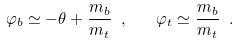Convert formula to latex. <formula><loc_0><loc_0><loc_500><loc_500>\varphi _ { b } \simeq - \theta + \frac { m _ { b } } { m _ { t } } \ , \quad \varphi _ { t } \simeq \frac { m _ { b } } { m _ { t } } \ .</formula> 